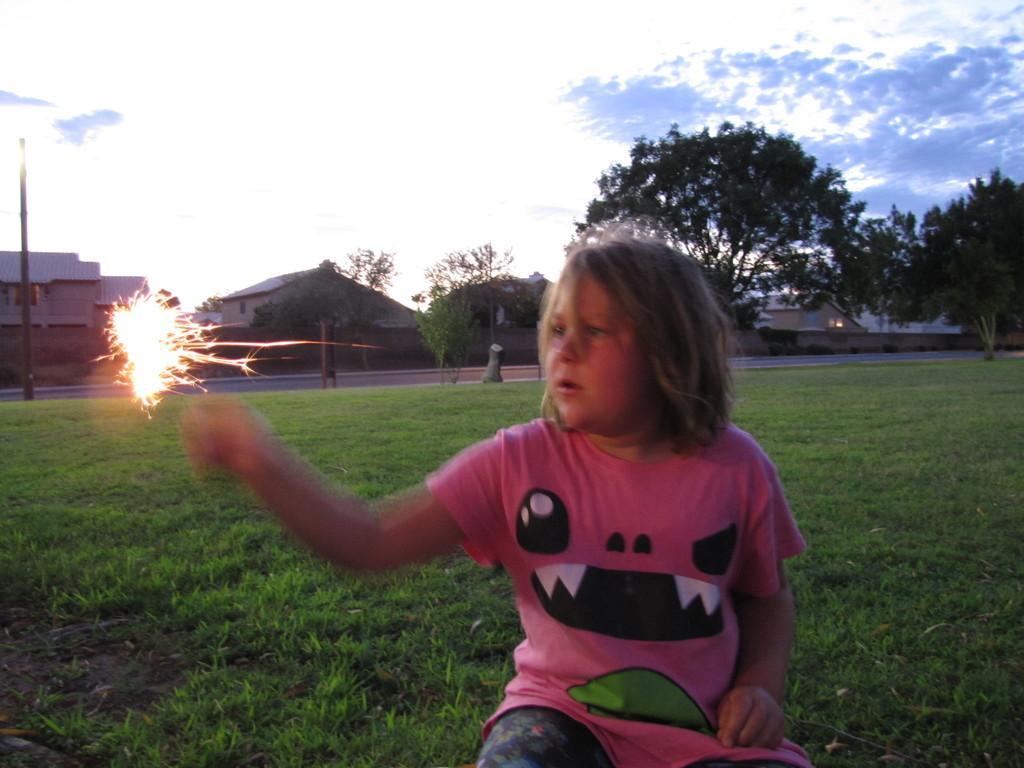Please provide a concise description of this image. In this image we can see a girl is sitting on the grassy land. She is wearing pink color t-shirt. Background trees and houses are present. The sky is full of clouds. 